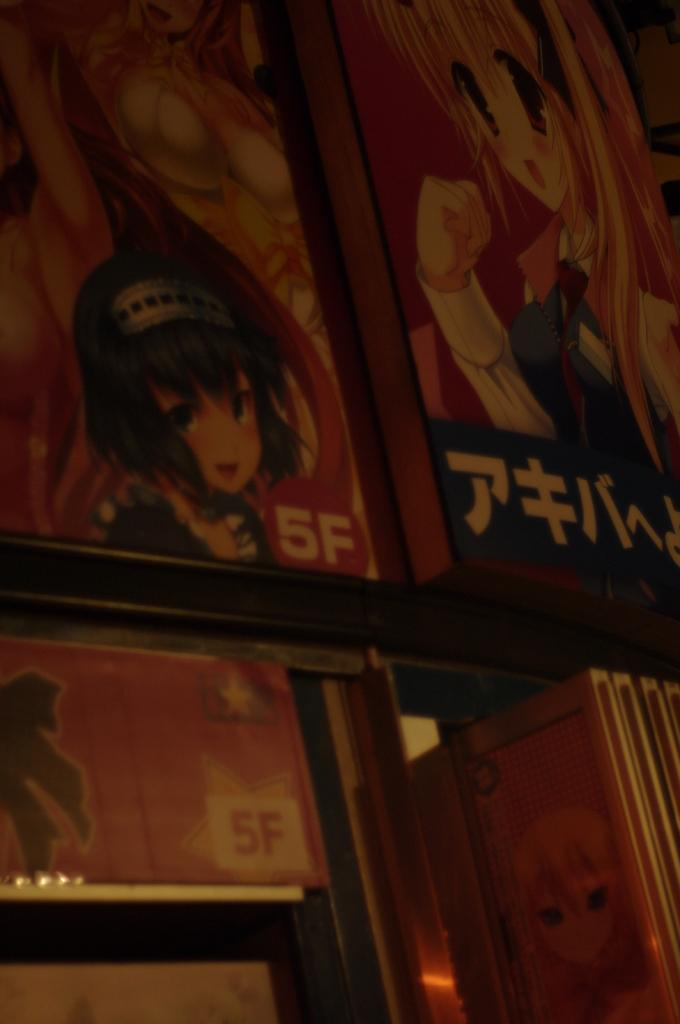What material are the boards in the image made of? The wooden boards in the image are made of wood. What is written or depicted on the wooden boards? There is text and cartoon images on the wooden boards. Can you describe the content of the cartoon images? Unfortunately, the specific content of the cartoon images cannot be determined from the provided facts. How many tomatoes are on the wooden boards in the image? There is no mention of tomatoes in the provided facts, so it cannot be determined if any are present in the image. 